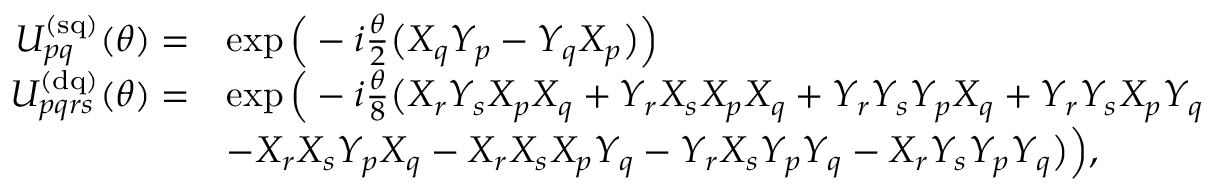Convert formula to latex. <formula><loc_0><loc_0><loc_500><loc_500>\begin{array} { r l } { U _ { p q } ^ { ( s q ) } ( \theta ) = } & { \exp \left ( - i \frac { \theta } { 2 } \left ( X _ { q } Y _ { p } - Y _ { q } X _ { p } \right ) \right ) } \\ { U _ { p q r s } ^ { ( d q ) } ( \theta ) = } & { \exp \left ( - i \frac { \theta } { 8 } \left ( X _ { r } Y _ { s } X _ { p } X _ { q } + Y _ { r } X _ { s } X _ { p } X _ { q } + Y _ { r } Y _ { s } Y _ { p } X _ { q } + Y _ { r } Y _ { s } X _ { p } Y _ { q } } \\ & { - X _ { r } X _ { s } Y _ { p } X _ { q } - X _ { r } X _ { s } X _ { p } Y _ { q } - Y _ { r } X _ { s } Y _ { p } Y _ { q } - X _ { r } Y _ { s } Y _ { p } Y _ { q } \right ) \right ) , } \end{array}</formula> 